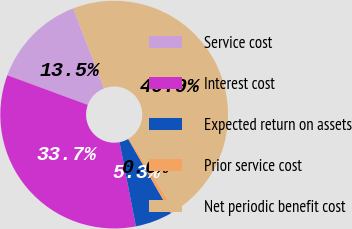<chart> <loc_0><loc_0><loc_500><loc_500><pie_chart><fcel>Service cost<fcel>Interest cost<fcel>Expected return on assets<fcel>Prior service cost<fcel>Net periodic benefit cost<nl><fcel>13.53%<fcel>33.68%<fcel>5.26%<fcel>0.63%<fcel>46.9%<nl></chart> 